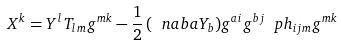Convert formula to latex. <formula><loc_0><loc_0><loc_500><loc_500>X ^ { k } = Y ^ { l } T _ { l m } g ^ { m k } - \frac { 1 } { 2 } \, ( \ n a b { a } Y _ { b } ) g ^ { a i } g ^ { b j } \ p h _ { i j m } g ^ { m k }</formula> 